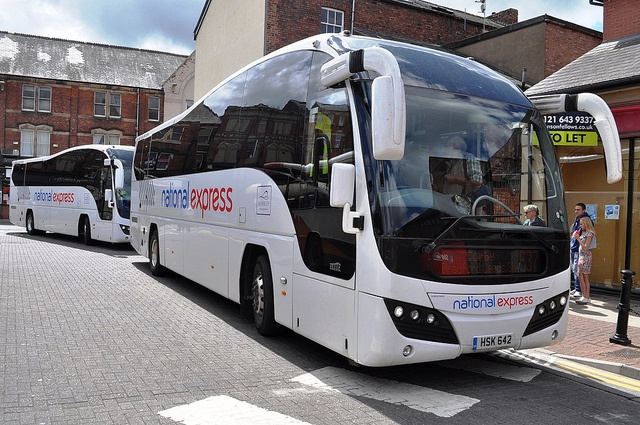Describe the objects in this image and their specific colors. I can see bus in white, black, darkgray, gray, and lightgray tones, bus in white, black, darkgray, and gray tones, people in white, black, gray, and darkblue tones, people in white, gray, darkgray, and maroon tones, and people in white, black, gray, brown, and ivory tones in this image. 